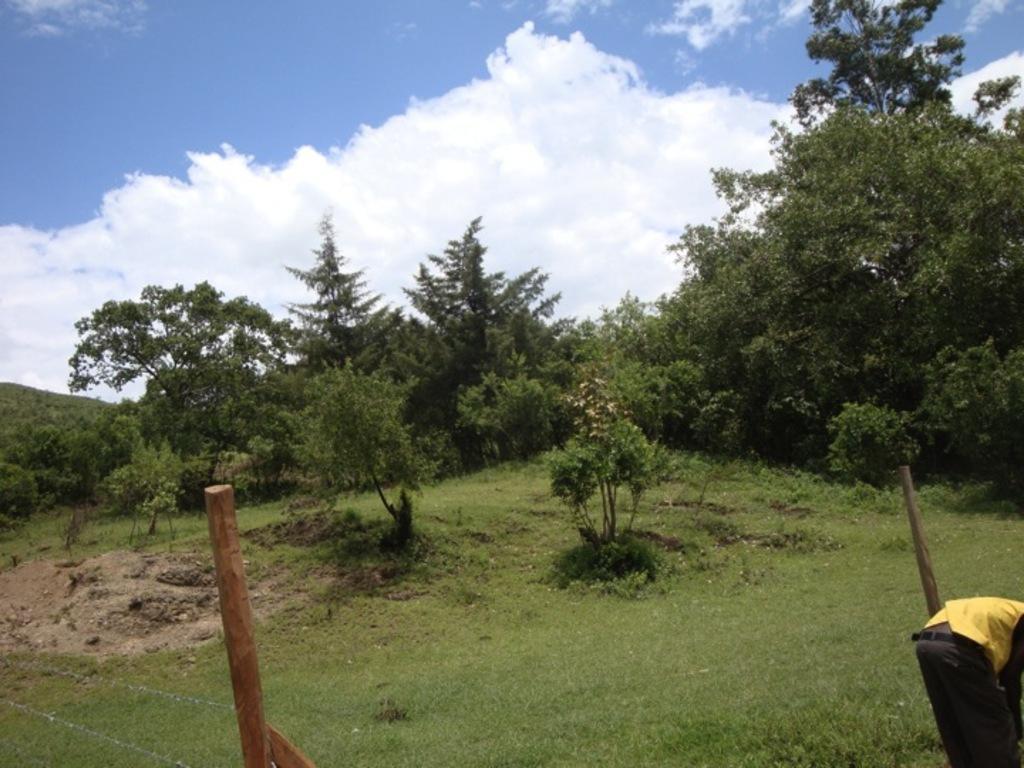In one or two sentences, can you explain what this image depicts? Left bottom of the picture there is a fence. Right bottom there is a person standing on the grassland having few plants and trees. Top of the image there is sky with some clouds. 